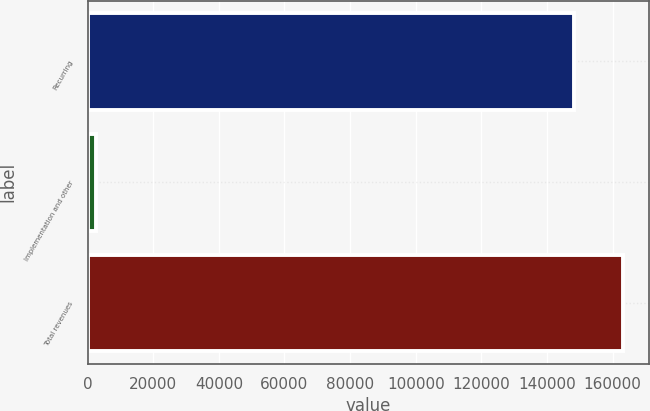Convert chart. <chart><loc_0><loc_0><loc_500><loc_500><bar_chart><fcel>Recurring<fcel>Implementation and other<fcel>Total revenues<nl><fcel>148207<fcel>2722<fcel>163028<nl></chart> 